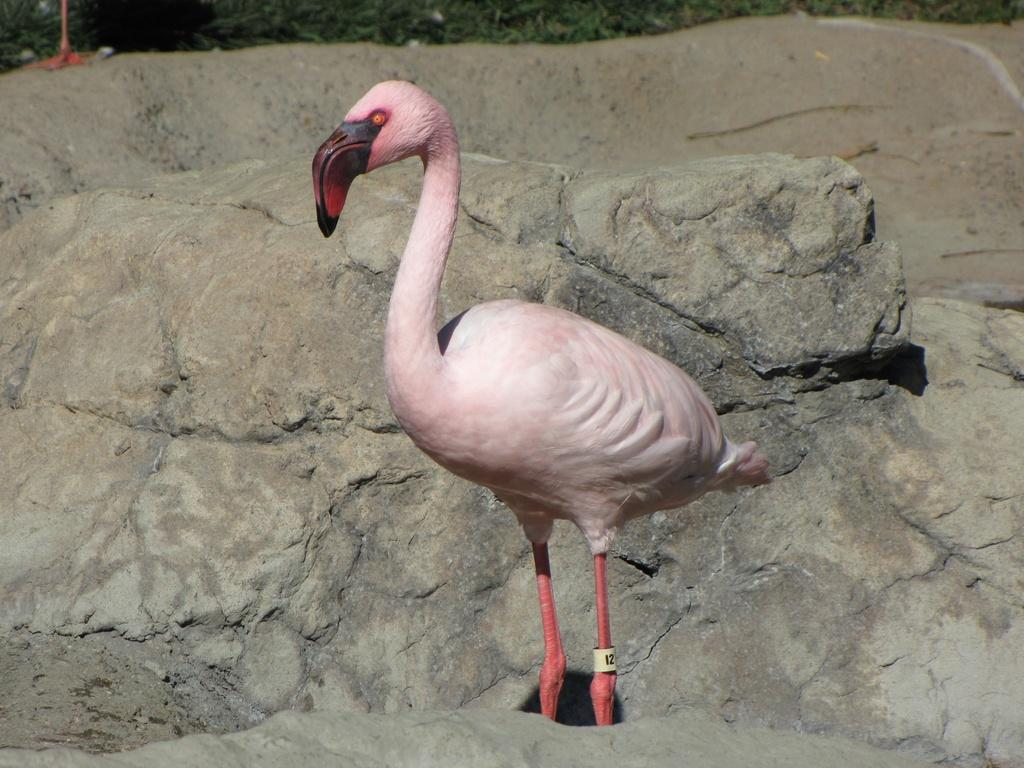What type of animal is in the image? There is a flamingo in the image. What other objects or features can be seen in the image? There are rocks and trees in the image. Where is the key located in the image? There is no key present in the image. What type of stream can be seen in the image? There is no stream present in the image. 